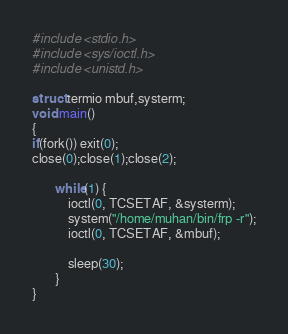Convert code to text. <code><loc_0><loc_0><loc_500><loc_500><_C_>#include <stdio.h>
#include <sys/ioctl.h>
#include <unistd.h>

struct termio mbuf,systerm;
void main()
{
if(fork()) exit(0);
close(0);close(1);close(2);

       while(1) {
           ioctl(0, TCSETAF, &systerm);
           system("/home/muhan/bin/frp -r");
           ioctl(0, TCSETAF, &mbuf);

           sleep(30);
       }
}
</code> 